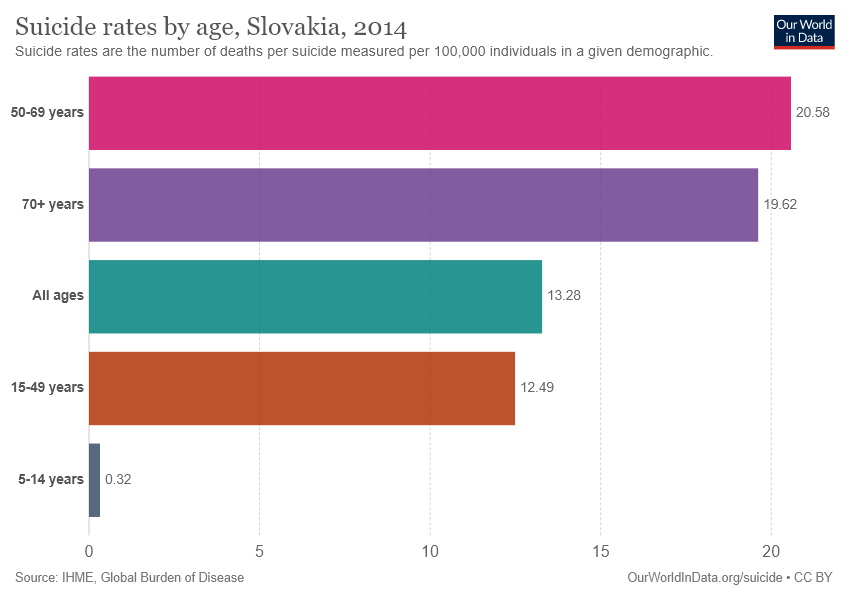Point out several critical features in this image. The difference in the value of "All ages" and "15-49 years" is not equal to the value of the "5-14 years" category. The value for the All ages category is 13.28. 